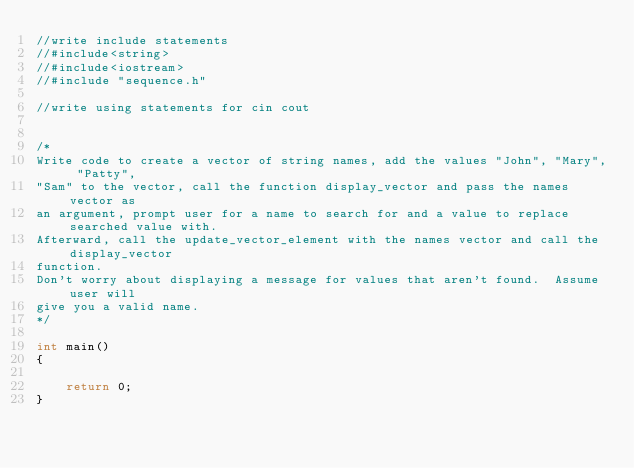Convert code to text. <code><loc_0><loc_0><loc_500><loc_500><_C++_>//write include statements
//#include<string>
//#include<iostream>
//#include "sequence.h"

//write using statements for cin cout


/*
Write code to create a vector of string names, add the values "John", "Mary", "Patty",
"Sam" to the vector, call the function display_vector and pass the names vector as
an argument, prompt user for a name to search for and a value to replace searched value with.
Afterward, call the update_vector_element with the names vector and call the display_vector
function.
Don't worry about displaying a message for values that aren't found.  Assume user will
give you a valid name.
*/

int main()
{

	return 0;
}

</code> 